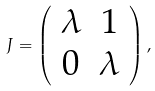Convert formula to latex. <formula><loc_0><loc_0><loc_500><loc_500>J = \left ( \begin{array} { c c } \lambda & 1 \\ 0 & \lambda \end{array} \right ) ,</formula> 